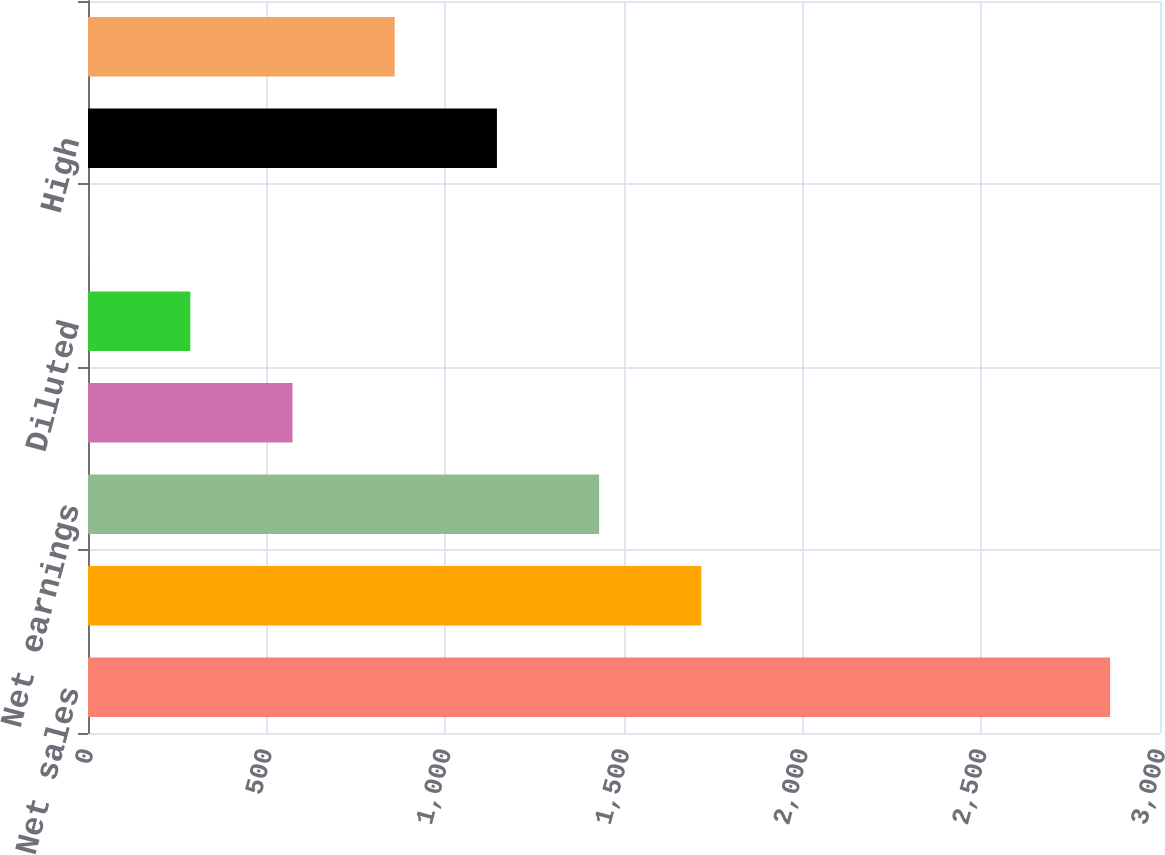Convert chart to OTSL. <chart><loc_0><loc_0><loc_500><loc_500><bar_chart><fcel>Net sales<fcel>Gross margin<fcel>Net earnings<fcel>Basic<fcel>Diluted<fcel>Dividends per share<fcel>High<fcel>Low<nl><fcel>2860.4<fcel>1716.4<fcel>1430.39<fcel>572.37<fcel>286.36<fcel>0.35<fcel>1144.38<fcel>858.38<nl></chart> 